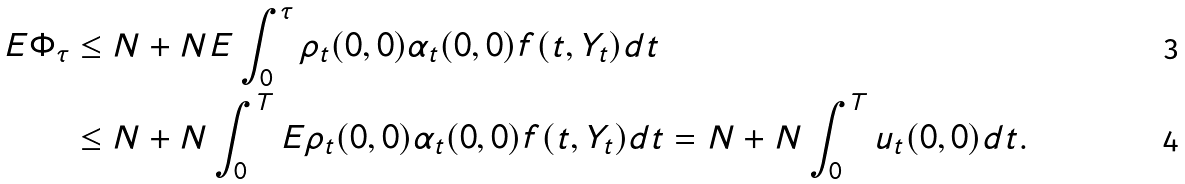<formula> <loc_0><loc_0><loc_500><loc_500>E \Phi _ { \tau } & \leq N + N E \int _ { 0 } ^ { \tau } \rho _ { t } ( 0 , 0 ) \alpha _ { t } ( 0 , 0 ) f ( t , Y _ { t } ) d t \\ & \leq N + N \int _ { 0 } ^ { T } E \rho _ { t } ( 0 , 0 ) \alpha _ { t } ( 0 , 0 ) f ( t , Y _ { t } ) d t = N + N \int _ { 0 } ^ { T } u _ { t } ( 0 , 0 ) d t .</formula> 